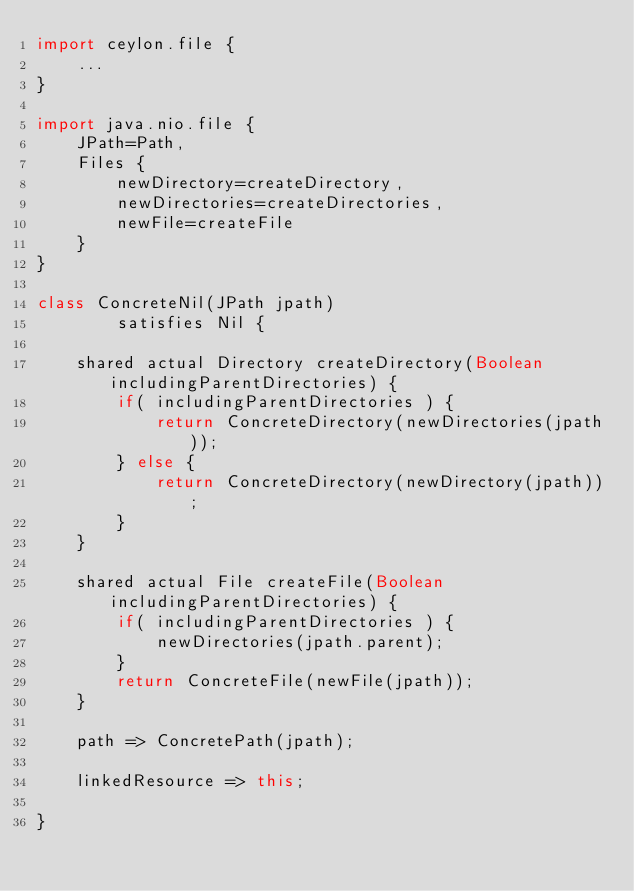<code> <loc_0><loc_0><loc_500><loc_500><_Ceylon_>import ceylon.file {
    ...
}

import java.nio.file {
    JPath=Path,
    Files {
        newDirectory=createDirectory,
        newDirectories=createDirectories,
        newFile=createFile
    }
}

class ConcreteNil(JPath jpath) 
        satisfies Nil {
    
    shared actual Directory createDirectory(Boolean includingParentDirectories) {
        if( includingParentDirectories ) {
            return ConcreteDirectory(newDirectories(jpath));
        } else {
            return ConcreteDirectory(newDirectory(jpath));
        }
    }
    
    shared actual File createFile(Boolean includingParentDirectories) {
        if( includingParentDirectories ) {
            newDirectories(jpath.parent);
        }
        return ConcreteFile(newFile(jpath));
    }
    
    path => ConcretePath(jpath); 
    
    linkedResource => this;
    
}</code> 